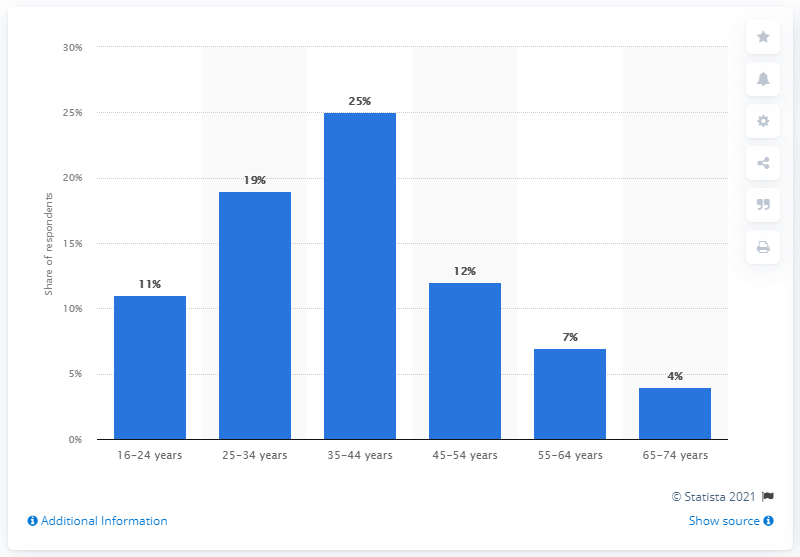Draw attention to some important aspects in this diagram. In 2018, male online shoppers accounted for approximately 12% of the total online shopper population. 